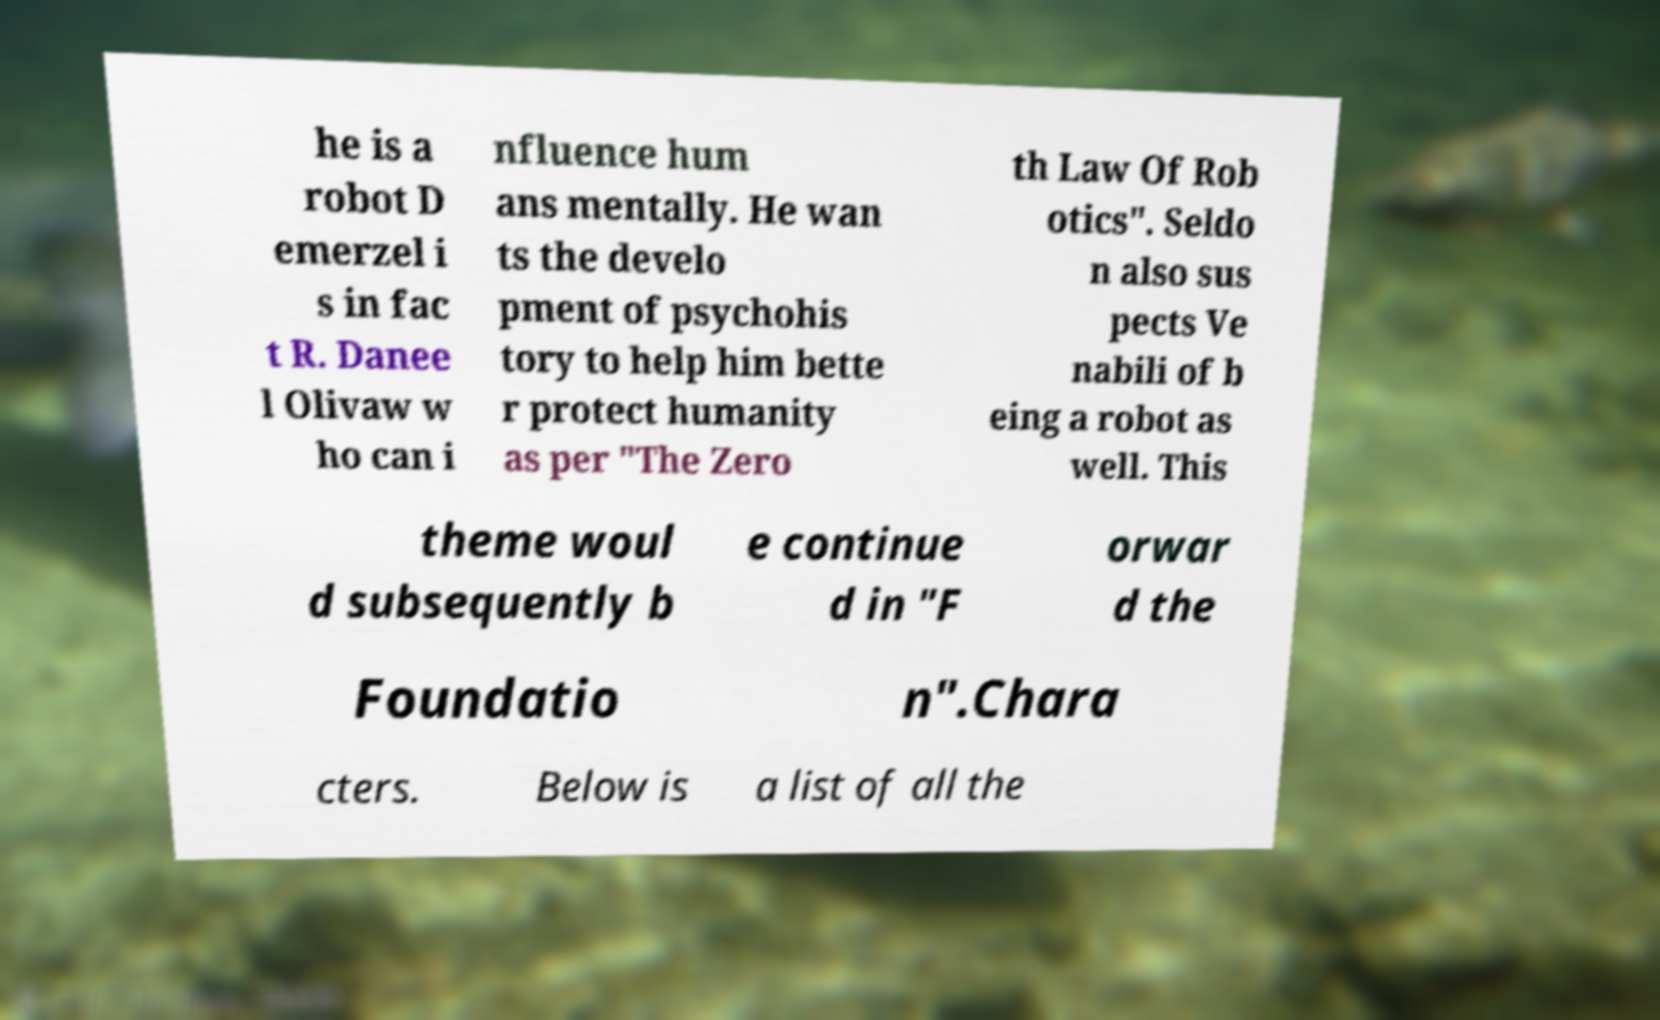Could you extract and type out the text from this image? he is a robot D emerzel i s in fac t R. Danee l Olivaw w ho can i nfluence hum ans mentally. He wan ts the develo pment of psychohis tory to help him bette r protect humanity as per "The Zero th Law Of Rob otics". Seldo n also sus pects Ve nabili of b eing a robot as well. This theme woul d subsequently b e continue d in "F orwar d the Foundatio n".Chara cters. Below is a list of all the 